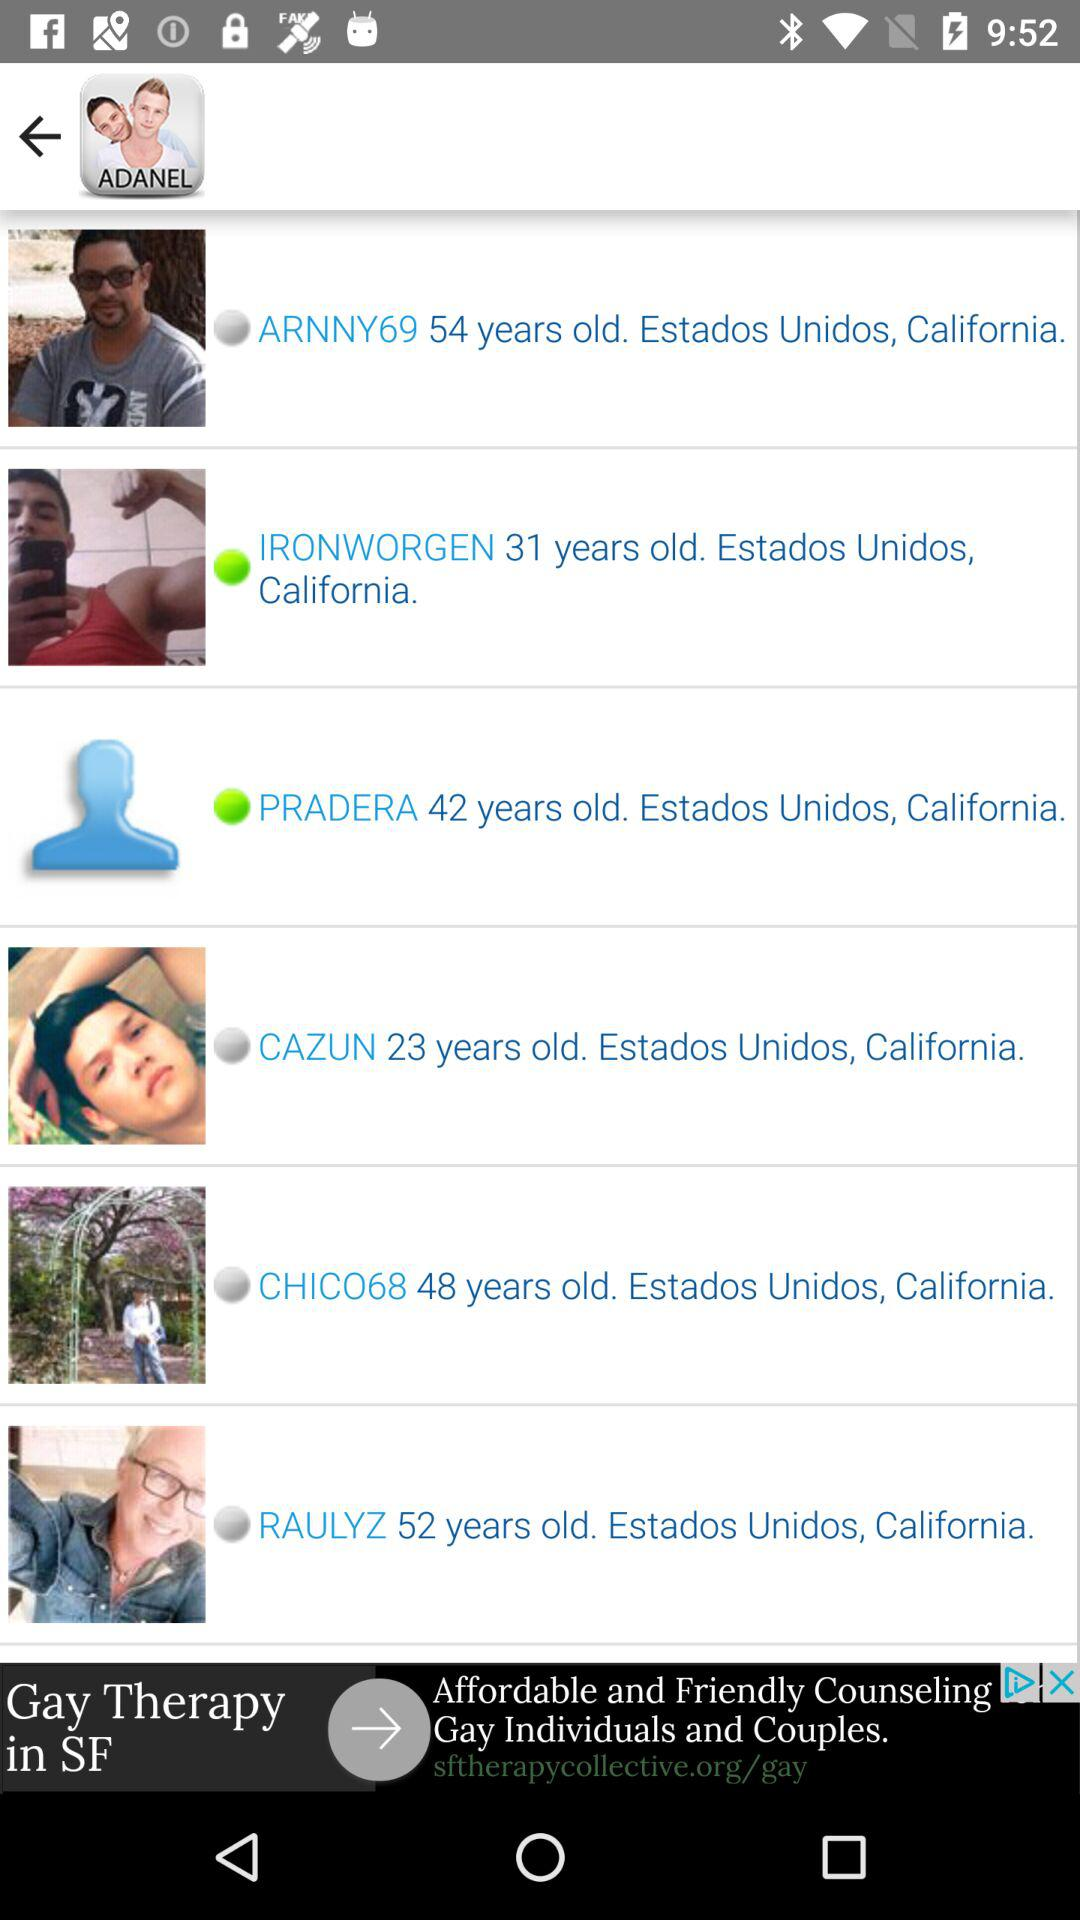What is the age of Pradera? Pradera is 42 years old. 